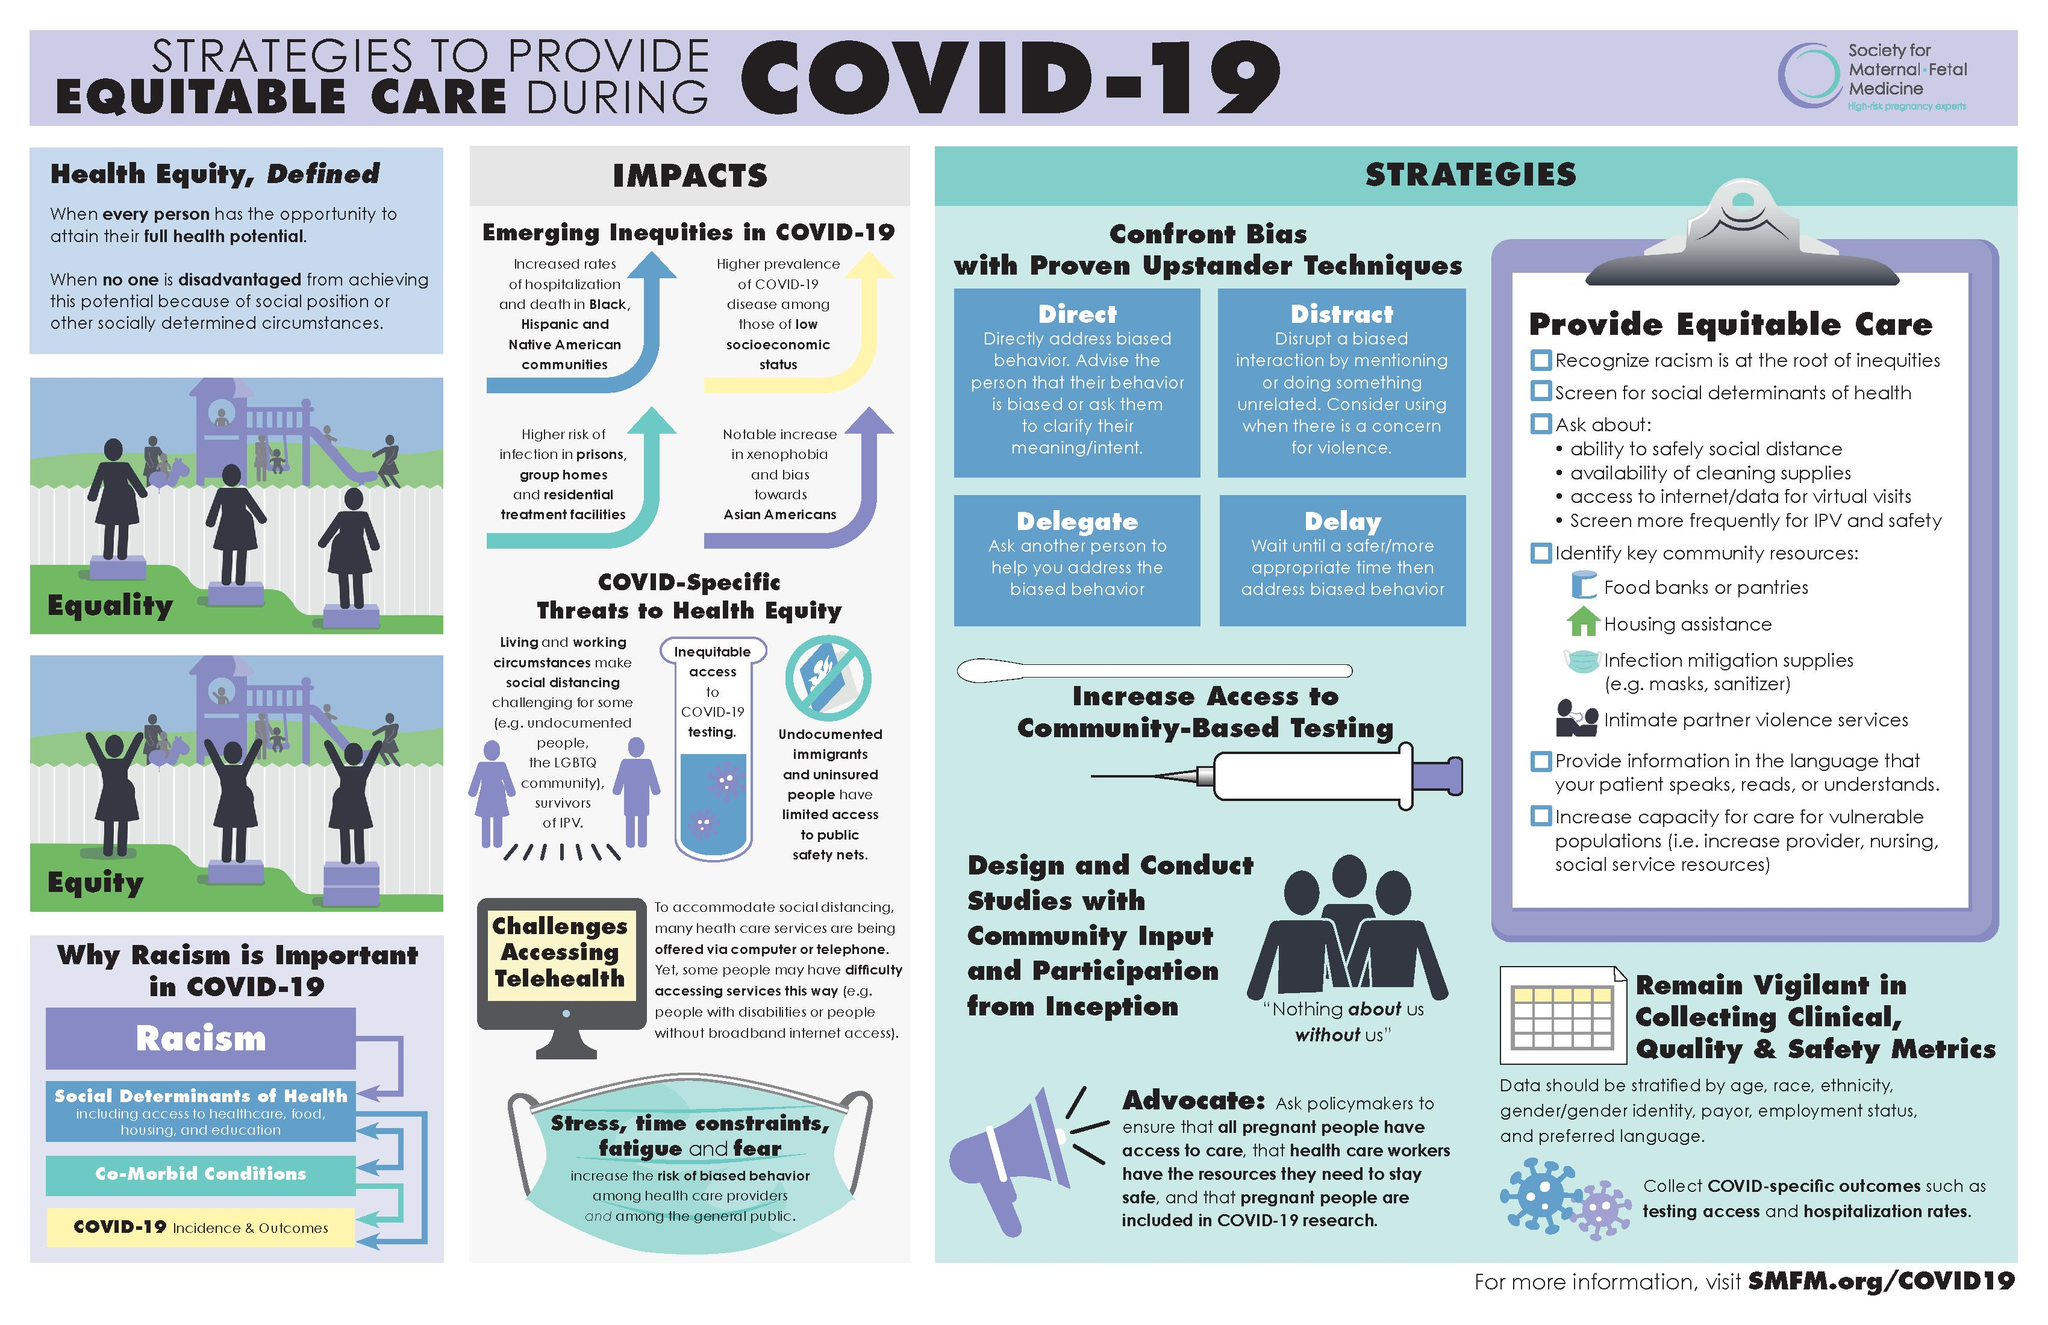Give some essential details in this illustration. The presence of four factors is associated with an increased risk of biased behavior. There are four community resources featured in this infographic. 